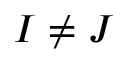Convert formula to latex. <formula><loc_0><loc_0><loc_500><loc_500>I \ne J</formula> 